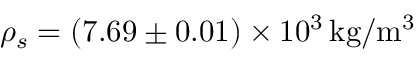Convert formula to latex. <formula><loc_0><loc_0><loc_500><loc_500>\rho _ { s } = \left ( 7 . 6 9 \pm 0 . 0 1 \right ) \times 1 0 ^ { 3 } \, k g / m ^ { 3 }</formula> 